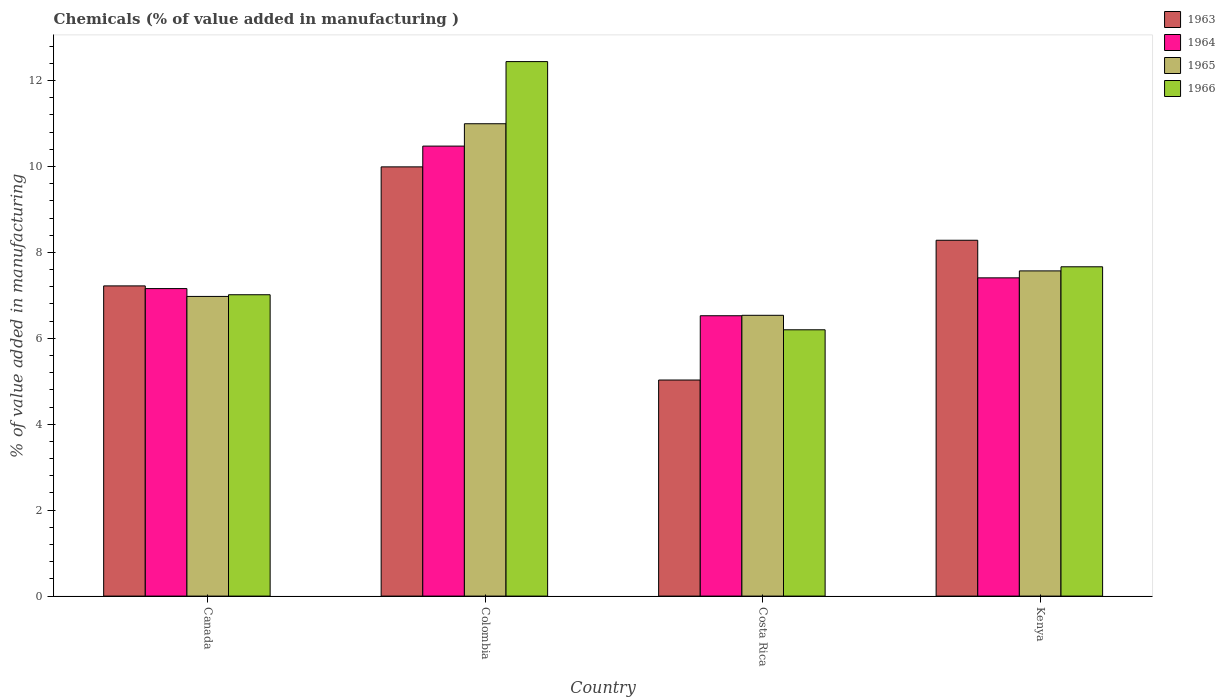How many different coloured bars are there?
Keep it short and to the point. 4. How many groups of bars are there?
Your response must be concise. 4. What is the label of the 4th group of bars from the left?
Your answer should be compact. Kenya. What is the value added in manufacturing chemicals in 1966 in Costa Rica?
Offer a terse response. 6.2. Across all countries, what is the maximum value added in manufacturing chemicals in 1965?
Offer a very short reply. 10.99. Across all countries, what is the minimum value added in manufacturing chemicals in 1963?
Provide a short and direct response. 5.03. What is the total value added in manufacturing chemicals in 1963 in the graph?
Give a very brief answer. 30.52. What is the difference between the value added in manufacturing chemicals in 1964 in Canada and that in Costa Rica?
Your answer should be very brief. 0.63. What is the difference between the value added in manufacturing chemicals in 1963 in Canada and the value added in manufacturing chemicals in 1966 in Colombia?
Your answer should be compact. -5.22. What is the average value added in manufacturing chemicals in 1963 per country?
Keep it short and to the point. 7.63. What is the difference between the value added in manufacturing chemicals of/in 1966 and value added in manufacturing chemicals of/in 1965 in Colombia?
Provide a short and direct response. 1.45. What is the ratio of the value added in manufacturing chemicals in 1966 in Canada to that in Costa Rica?
Make the answer very short. 1.13. Is the value added in manufacturing chemicals in 1964 in Canada less than that in Kenya?
Offer a very short reply. Yes. What is the difference between the highest and the second highest value added in manufacturing chemicals in 1963?
Your answer should be compact. -1.71. What is the difference between the highest and the lowest value added in manufacturing chemicals in 1964?
Make the answer very short. 3.95. In how many countries, is the value added in manufacturing chemicals in 1966 greater than the average value added in manufacturing chemicals in 1966 taken over all countries?
Keep it short and to the point. 1. What does the 4th bar from the left in Canada represents?
Your answer should be very brief. 1966. What does the 3rd bar from the right in Canada represents?
Keep it short and to the point. 1964. Is it the case that in every country, the sum of the value added in manufacturing chemicals in 1966 and value added in manufacturing chemicals in 1964 is greater than the value added in manufacturing chemicals in 1963?
Your answer should be very brief. Yes. Are all the bars in the graph horizontal?
Make the answer very short. No. How many countries are there in the graph?
Provide a short and direct response. 4. Are the values on the major ticks of Y-axis written in scientific E-notation?
Provide a succinct answer. No. Does the graph contain any zero values?
Your response must be concise. No. Does the graph contain grids?
Ensure brevity in your answer.  No. How many legend labels are there?
Provide a short and direct response. 4. How are the legend labels stacked?
Make the answer very short. Vertical. What is the title of the graph?
Keep it short and to the point. Chemicals (% of value added in manufacturing ). Does "1991" appear as one of the legend labels in the graph?
Offer a terse response. No. What is the label or title of the Y-axis?
Offer a terse response. % of value added in manufacturing. What is the % of value added in manufacturing in 1963 in Canada?
Provide a succinct answer. 7.22. What is the % of value added in manufacturing of 1964 in Canada?
Give a very brief answer. 7.16. What is the % of value added in manufacturing of 1965 in Canada?
Keep it short and to the point. 6.98. What is the % of value added in manufacturing in 1966 in Canada?
Your answer should be very brief. 7.01. What is the % of value added in manufacturing in 1963 in Colombia?
Provide a succinct answer. 9.99. What is the % of value added in manufacturing of 1964 in Colombia?
Your response must be concise. 10.47. What is the % of value added in manufacturing in 1965 in Colombia?
Keep it short and to the point. 10.99. What is the % of value added in manufacturing in 1966 in Colombia?
Your answer should be compact. 12.44. What is the % of value added in manufacturing in 1963 in Costa Rica?
Ensure brevity in your answer.  5.03. What is the % of value added in manufacturing of 1964 in Costa Rica?
Your answer should be compact. 6.53. What is the % of value added in manufacturing in 1965 in Costa Rica?
Keep it short and to the point. 6.54. What is the % of value added in manufacturing in 1966 in Costa Rica?
Provide a succinct answer. 6.2. What is the % of value added in manufacturing of 1963 in Kenya?
Your answer should be compact. 8.28. What is the % of value added in manufacturing of 1964 in Kenya?
Ensure brevity in your answer.  7.41. What is the % of value added in manufacturing of 1965 in Kenya?
Give a very brief answer. 7.57. What is the % of value added in manufacturing in 1966 in Kenya?
Provide a short and direct response. 7.67. Across all countries, what is the maximum % of value added in manufacturing in 1963?
Keep it short and to the point. 9.99. Across all countries, what is the maximum % of value added in manufacturing of 1964?
Your response must be concise. 10.47. Across all countries, what is the maximum % of value added in manufacturing in 1965?
Provide a succinct answer. 10.99. Across all countries, what is the maximum % of value added in manufacturing of 1966?
Offer a terse response. 12.44. Across all countries, what is the minimum % of value added in manufacturing in 1963?
Keep it short and to the point. 5.03. Across all countries, what is the minimum % of value added in manufacturing in 1964?
Provide a succinct answer. 6.53. Across all countries, what is the minimum % of value added in manufacturing in 1965?
Ensure brevity in your answer.  6.54. Across all countries, what is the minimum % of value added in manufacturing in 1966?
Ensure brevity in your answer.  6.2. What is the total % of value added in manufacturing of 1963 in the graph?
Offer a very short reply. 30.52. What is the total % of value added in manufacturing in 1964 in the graph?
Provide a short and direct response. 31.57. What is the total % of value added in manufacturing in 1965 in the graph?
Give a very brief answer. 32.08. What is the total % of value added in manufacturing of 1966 in the graph?
Make the answer very short. 33.32. What is the difference between the % of value added in manufacturing of 1963 in Canada and that in Colombia?
Your answer should be very brief. -2.77. What is the difference between the % of value added in manufacturing in 1964 in Canada and that in Colombia?
Keep it short and to the point. -3.32. What is the difference between the % of value added in manufacturing in 1965 in Canada and that in Colombia?
Keep it short and to the point. -4.02. What is the difference between the % of value added in manufacturing of 1966 in Canada and that in Colombia?
Give a very brief answer. -5.43. What is the difference between the % of value added in manufacturing of 1963 in Canada and that in Costa Rica?
Your response must be concise. 2.19. What is the difference between the % of value added in manufacturing in 1964 in Canada and that in Costa Rica?
Ensure brevity in your answer.  0.63. What is the difference between the % of value added in manufacturing in 1965 in Canada and that in Costa Rica?
Ensure brevity in your answer.  0.44. What is the difference between the % of value added in manufacturing in 1966 in Canada and that in Costa Rica?
Provide a succinct answer. 0.82. What is the difference between the % of value added in manufacturing in 1963 in Canada and that in Kenya?
Offer a very short reply. -1.06. What is the difference between the % of value added in manufacturing in 1964 in Canada and that in Kenya?
Your answer should be very brief. -0.25. What is the difference between the % of value added in manufacturing of 1965 in Canada and that in Kenya?
Offer a very short reply. -0.59. What is the difference between the % of value added in manufacturing of 1966 in Canada and that in Kenya?
Keep it short and to the point. -0.65. What is the difference between the % of value added in manufacturing in 1963 in Colombia and that in Costa Rica?
Your answer should be compact. 4.96. What is the difference between the % of value added in manufacturing of 1964 in Colombia and that in Costa Rica?
Your answer should be very brief. 3.95. What is the difference between the % of value added in manufacturing of 1965 in Colombia and that in Costa Rica?
Offer a terse response. 4.46. What is the difference between the % of value added in manufacturing of 1966 in Colombia and that in Costa Rica?
Your answer should be very brief. 6.24. What is the difference between the % of value added in manufacturing in 1963 in Colombia and that in Kenya?
Ensure brevity in your answer.  1.71. What is the difference between the % of value added in manufacturing in 1964 in Colombia and that in Kenya?
Your response must be concise. 3.07. What is the difference between the % of value added in manufacturing in 1965 in Colombia and that in Kenya?
Provide a succinct answer. 3.43. What is the difference between the % of value added in manufacturing of 1966 in Colombia and that in Kenya?
Provide a succinct answer. 4.78. What is the difference between the % of value added in manufacturing of 1963 in Costa Rica and that in Kenya?
Provide a short and direct response. -3.25. What is the difference between the % of value added in manufacturing of 1964 in Costa Rica and that in Kenya?
Provide a short and direct response. -0.88. What is the difference between the % of value added in manufacturing in 1965 in Costa Rica and that in Kenya?
Your response must be concise. -1.03. What is the difference between the % of value added in manufacturing of 1966 in Costa Rica and that in Kenya?
Provide a succinct answer. -1.47. What is the difference between the % of value added in manufacturing of 1963 in Canada and the % of value added in manufacturing of 1964 in Colombia?
Make the answer very short. -3.25. What is the difference between the % of value added in manufacturing in 1963 in Canada and the % of value added in manufacturing in 1965 in Colombia?
Your answer should be compact. -3.77. What is the difference between the % of value added in manufacturing in 1963 in Canada and the % of value added in manufacturing in 1966 in Colombia?
Offer a terse response. -5.22. What is the difference between the % of value added in manufacturing of 1964 in Canada and the % of value added in manufacturing of 1965 in Colombia?
Offer a very short reply. -3.84. What is the difference between the % of value added in manufacturing of 1964 in Canada and the % of value added in manufacturing of 1966 in Colombia?
Your answer should be compact. -5.28. What is the difference between the % of value added in manufacturing in 1965 in Canada and the % of value added in manufacturing in 1966 in Colombia?
Offer a very short reply. -5.47. What is the difference between the % of value added in manufacturing in 1963 in Canada and the % of value added in manufacturing in 1964 in Costa Rica?
Ensure brevity in your answer.  0.69. What is the difference between the % of value added in manufacturing in 1963 in Canada and the % of value added in manufacturing in 1965 in Costa Rica?
Ensure brevity in your answer.  0.68. What is the difference between the % of value added in manufacturing in 1963 in Canada and the % of value added in manufacturing in 1966 in Costa Rica?
Give a very brief answer. 1.02. What is the difference between the % of value added in manufacturing in 1964 in Canada and the % of value added in manufacturing in 1965 in Costa Rica?
Offer a terse response. 0.62. What is the difference between the % of value added in manufacturing in 1964 in Canada and the % of value added in manufacturing in 1966 in Costa Rica?
Make the answer very short. 0.96. What is the difference between the % of value added in manufacturing of 1965 in Canada and the % of value added in manufacturing of 1966 in Costa Rica?
Make the answer very short. 0.78. What is the difference between the % of value added in manufacturing of 1963 in Canada and the % of value added in manufacturing of 1964 in Kenya?
Provide a short and direct response. -0.19. What is the difference between the % of value added in manufacturing of 1963 in Canada and the % of value added in manufacturing of 1965 in Kenya?
Keep it short and to the point. -0.35. What is the difference between the % of value added in manufacturing in 1963 in Canada and the % of value added in manufacturing in 1966 in Kenya?
Offer a very short reply. -0.44. What is the difference between the % of value added in manufacturing of 1964 in Canada and the % of value added in manufacturing of 1965 in Kenya?
Offer a very short reply. -0.41. What is the difference between the % of value added in manufacturing of 1964 in Canada and the % of value added in manufacturing of 1966 in Kenya?
Provide a short and direct response. -0.51. What is the difference between the % of value added in manufacturing of 1965 in Canada and the % of value added in manufacturing of 1966 in Kenya?
Keep it short and to the point. -0.69. What is the difference between the % of value added in manufacturing in 1963 in Colombia and the % of value added in manufacturing in 1964 in Costa Rica?
Give a very brief answer. 3.47. What is the difference between the % of value added in manufacturing of 1963 in Colombia and the % of value added in manufacturing of 1965 in Costa Rica?
Your response must be concise. 3.46. What is the difference between the % of value added in manufacturing in 1963 in Colombia and the % of value added in manufacturing in 1966 in Costa Rica?
Offer a very short reply. 3.79. What is the difference between the % of value added in manufacturing of 1964 in Colombia and the % of value added in manufacturing of 1965 in Costa Rica?
Ensure brevity in your answer.  3.94. What is the difference between the % of value added in manufacturing of 1964 in Colombia and the % of value added in manufacturing of 1966 in Costa Rica?
Provide a short and direct response. 4.28. What is the difference between the % of value added in manufacturing in 1965 in Colombia and the % of value added in manufacturing in 1966 in Costa Rica?
Ensure brevity in your answer.  4.8. What is the difference between the % of value added in manufacturing in 1963 in Colombia and the % of value added in manufacturing in 1964 in Kenya?
Give a very brief answer. 2.58. What is the difference between the % of value added in manufacturing in 1963 in Colombia and the % of value added in manufacturing in 1965 in Kenya?
Provide a short and direct response. 2.42. What is the difference between the % of value added in manufacturing in 1963 in Colombia and the % of value added in manufacturing in 1966 in Kenya?
Keep it short and to the point. 2.33. What is the difference between the % of value added in manufacturing in 1964 in Colombia and the % of value added in manufacturing in 1965 in Kenya?
Keep it short and to the point. 2.9. What is the difference between the % of value added in manufacturing of 1964 in Colombia and the % of value added in manufacturing of 1966 in Kenya?
Give a very brief answer. 2.81. What is the difference between the % of value added in manufacturing in 1965 in Colombia and the % of value added in manufacturing in 1966 in Kenya?
Your answer should be very brief. 3.33. What is the difference between the % of value added in manufacturing in 1963 in Costa Rica and the % of value added in manufacturing in 1964 in Kenya?
Ensure brevity in your answer.  -2.38. What is the difference between the % of value added in manufacturing in 1963 in Costa Rica and the % of value added in manufacturing in 1965 in Kenya?
Provide a succinct answer. -2.54. What is the difference between the % of value added in manufacturing in 1963 in Costa Rica and the % of value added in manufacturing in 1966 in Kenya?
Offer a terse response. -2.64. What is the difference between the % of value added in manufacturing of 1964 in Costa Rica and the % of value added in manufacturing of 1965 in Kenya?
Your answer should be compact. -1.04. What is the difference between the % of value added in manufacturing of 1964 in Costa Rica and the % of value added in manufacturing of 1966 in Kenya?
Provide a succinct answer. -1.14. What is the difference between the % of value added in manufacturing of 1965 in Costa Rica and the % of value added in manufacturing of 1966 in Kenya?
Make the answer very short. -1.13. What is the average % of value added in manufacturing in 1963 per country?
Your answer should be compact. 7.63. What is the average % of value added in manufacturing of 1964 per country?
Offer a very short reply. 7.89. What is the average % of value added in manufacturing of 1965 per country?
Offer a terse response. 8.02. What is the average % of value added in manufacturing of 1966 per country?
Your answer should be compact. 8.33. What is the difference between the % of value added in manufacturing in 1963 and % of value added in manufacturing in 1964 in Canada?
Ensure brevity in your answer.  0.06. What is the difference between the % of value added in manufacturing of 1963 and % of value added in manufacturing of 1965 in Canada?
Your response must be concise. 0.25. What is the difference between the % of value added in manufacturing in 1963 and % of value added in manufacturing in 1966 in Canada?
Your answer should be compact. 0.21. What is the difference between the % of value added in manufacturing in 1964 and % of value added in manufacturing in 1965 in Canada?
Your answer should be compact. 0.18. What is the difference between the % of value added in manufacturing in 1964 and % of value added in manufacturing in 1966 in Canada?
Offer a terse response. 0.14. What is the difference between the % of value added in manufacturing in 1965 and % of value added in manufacturing in 1966 in Canada?
Provide a succinct answer. -0.04. What is the difference between the % of value added in manufacturing in 1963 and % of value added in manufacturing in 1964 in Colombia?
Offer a terse response. -0.48. What is the difference between the % of value added in manufacturing in 1963 and % of value added in manufacturing in 1965 in Colombia?
Offer a very short reply. -1. What is the difference between the % of value added in manufacturing in 1963 and % of value added in manufacturing in 1966 in Colombia?
Offer a terse response. -2.45. What is the difference between the % of value added in manufacturing of 1964 and % of value added in manufacturing of 1965 in Colombia?
Offer a very short reply. -0.52. What is the difference between the % of value added in manufacturing of 1964 and % of value added in manufacturing of 1966 in Colombia?
Make the answer very short. -1.97. What is the difference between the % of value added in manufacturing of 1965 and % of value added in manufacturing of 1966 in Colombia?
Provide a succinct answer. -1.45. What is the difference between the % of value added in manufacturing of 1963 and % of value added in manufacturing of 1964 in Costa Rica?
Make the answer very short. -1.5. What is the difference between the % of value added in manufacturing of 1963 and % of value added in manufacturing of 1965 in Costa Rica?
Provide a succinct answer. -1.51. What is the difference between the % of value added in manufacturing in 1963 and % of value added in manufacturing in 1966 in Costa Rica?
Offer a very short reply. -1.17. What is the difference between the % of value added in manufacturing of 1964 and % of value added in manufacturing of 1965 in Costa Rica?
Your answer should be very brief. -0.01. What is the difference between the % of value added in manufacturing in 1964 and % of value added in manufacturing in 1966 in Costa Rica?
Your answer should be compact. 0.33. What is the difference between the % of value added in manufacturing of 1965 and % of value added in manufacturing of 1966 in Costa Rica?
Your answer should be compact. 0.34. What is the difference between the % of value added in manufacturing in 1963 and % of value added in manufacturing in 1964 in Kenya?
Give a very brief answer. 0.87. What is the difference between the % of value added in manufacturing in 1963 and % of value added in manufacturing in 1965 in Kenya?
Offer a terse response. 0.71. What is the difference between the % of value added in manufacturing in 1963 and % of value added in manufacturing in 1966 in Kenya?
Provide a short and direct response. 0.62. What is the difference between the % of value added in manufacturing of 1964 and % of value added in manufacturing of 1965 in Kenya?
Your response must be concise. -0.16. What is the difference between the % of value added in manufacturing in 1964 and % of value added in manufacturing in 1966 in Kenya?
Offer a terse response. -0.26. What is the difference between the % of value added in manufacturing of 1965 and % of value added in manufacturing of 1966 in Kenya?
Offer a terse response. -0.1. What is the ratio of the % of value added in manufacturing in 1963 in Canada to that in Colombia?
Offer a very short reply. 0.72. What is the ratio of the % of value added in manufacturing in 1964 in Canada to that in Colombia?
Provide a short and direct response. 0.68. What is the ratio of the % of value added in manufacturing of 1965 in Canada to that in Colombia?
Make the answer very short. 0.63. What is the ratio of the % of value added in manufacturing in 1966 in Canada to that in Colombia?
Provide a succinct answer. 0.56. What is the ratio of the % of value added in manufacturing in 1963 in Canada to that in Costa Rica?
Provide a short and direct response. 1.44. What is the ratio of the % of value added in manufacturing of 1964 in Canada to that in Costa Rica?
Your response must be concise. 1.1. What is the ratio of the % of value added in manufacturing of 1965 in Canada to that in Costa Rica?
Your response must be concise. 1.07. What is the ratio of the % of value added in manufacturing of 1966 in Canada to that in Costa Rica?
Your answer should be very brief. 1.13. What is the ratio of the % of value added in manufacturing in 1963 in Canada to that in Kenya?
Your answer should be compact. 0.87. What is the ratio of the % of value added in manufacturing in 1964 in Canada to that in Kenya?
Your response must be concise. 0.97. What is the ratio of the % of value added in manufacturing of 1965 in Canada to that in Kenya?
Keep it short and to the point. 0.92. What is the ratio of the % of value added in manufacturing in 1966 in Canada to that in Kenya?
Your response must be concise. 0.92. What is the ratio of the % of value added in manufacturing in 1963 in Colombia to that in Costa Rica?
Your answer should be very brief. 1.99. What is the ratio of the % of value added in manufacturing in 1964 in Colombia to that in Costa Rica?
Provide a short and direct response. 1.61. What is the ratio of the % of value added in manufacturing of 1965 in Colombia to that in Costa Rica?
Keep it short and to the point. 1.68. What is the ratio of the % of value added in manufacturing in 1966 in Colombia to that in Costa Rica?
Your answer should be compact. 2.01. What is the ratio of the % of value added in manufacturing of 1963 in Colombia to that in Kenya?
Offer a terse response. 1.21. What is the ratio of the % of value added in manufacturing in 1964 in Colombia to that in Kenya?
Ensure brevity in your answer.  1.41. What is the ratio of the % of value added in manufacturing in 1965 in Colombia to that in Kenya?
Give a very brief answer. 1.45. What is the ratio of the % of value added in manufacturing of 1966 in Colombia to that in Kenya?
Keep it short and to the point. 1.62. What is the ratio of the % of value added in manufacturing in 1963 in Costa Rica to that in Kenya?
Ensure brevity in your answer.  0.61. What is the ratio of the % of value added in manufacturing in 1964 in Costa Rica to that in Kenya?
Provide a short and direct response. 0.88. What is the ratio of the % of value added in manufacturing in 1965 in Costa Rica to that in Kenya?
Offer a terse response. 0.86. What is the ratio of the % of value added in manufacturing in 1966 in Costa Rica to that in Kenya?
Your answer should be compact. 0.81. What is the difference between the highest and the second highest % of value added in manufacturing of 1963?
Your response must be concise. 1.71. What is the difference between the highest and the second highest % of value added in manufacturing in 1964?
Your answer should be compact. 3.07. What is the difference between the highest and the second highest % of value added in manufacturing in 1965?
Keep it short and to the point. 3.43. What is the difference between the highest and the second highest % of value added in manufacturing of 1966?
Offer a terse response. 4.78. What is the difference between the highest and the lowest % of value added in manufacturing in 1963?
Give a very brief answer. 4.96. What is the difference between the highest and the lowest % of value added in manufacturing in 1964?
Give a very brief answer. 3.95. What is the difference between the highest and the lowest % of value added in manufacturing in 1965?
Your response must be concise. 4.46. What is the difference between the highest and the lowest % of value added in manufacturing in 1966?
Ensure brevity in your answer.  6.24. 